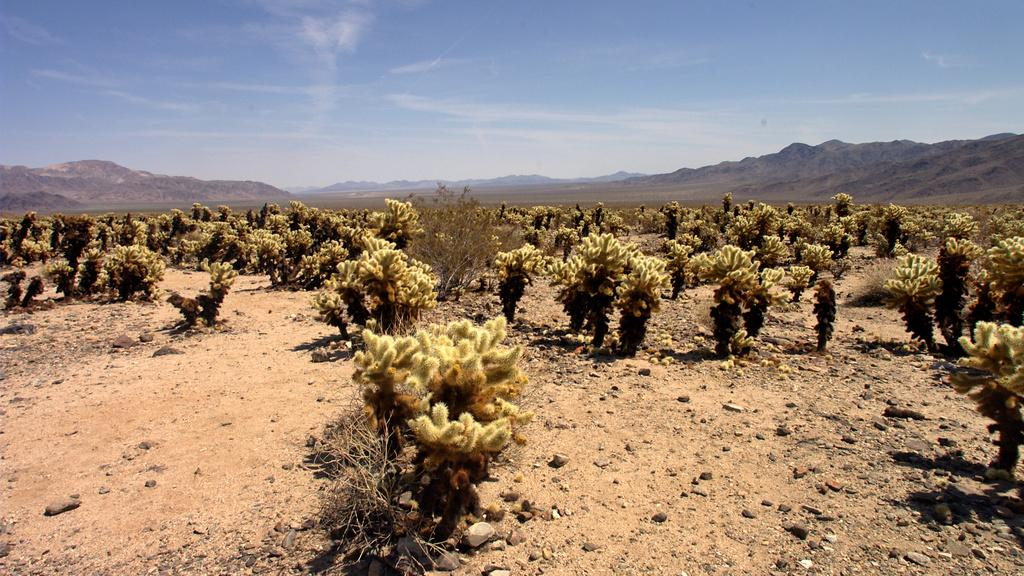What type of living organisms can be seen in the image? Plants can be seen in the image. What geographical feature is located in the middle of the image? There are hills in the middle of the image. What is visible at the top of the image? The sky is visible at the top of the image. How many carts are present in the image? There are no carts present in the image. What feelings are expressed by the plants in the image? Plants do not have feelings, so this cannot be determined from the image. 